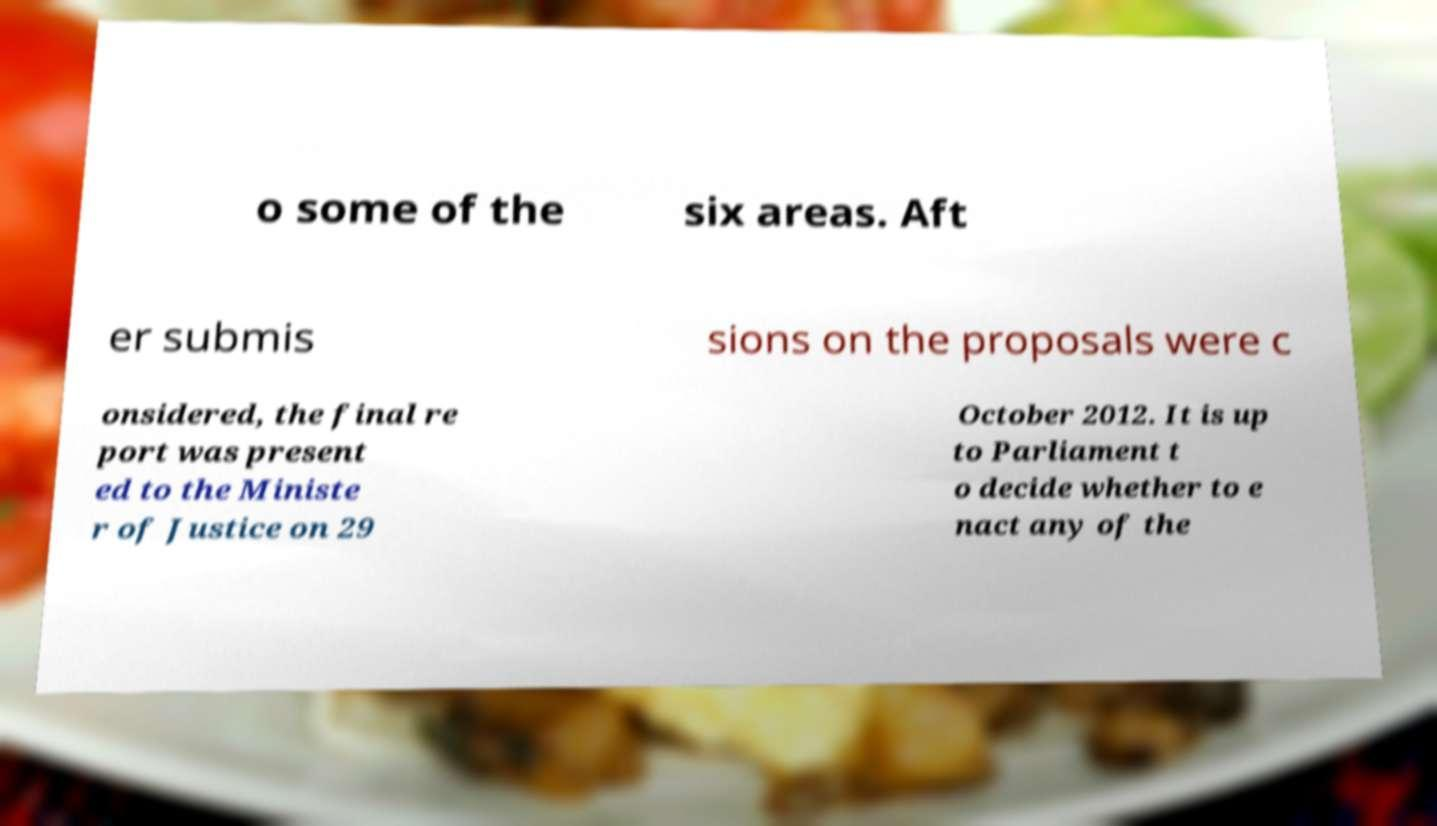Please identify and transcribe the text found in this image. o some of the six areas. Aft er submis sions on the proposals were c onsidered, the final re port was present ed to the Ministe r of Justice on 29 October 2012. It is up to Parliament t o decide whether to e nact any of the 